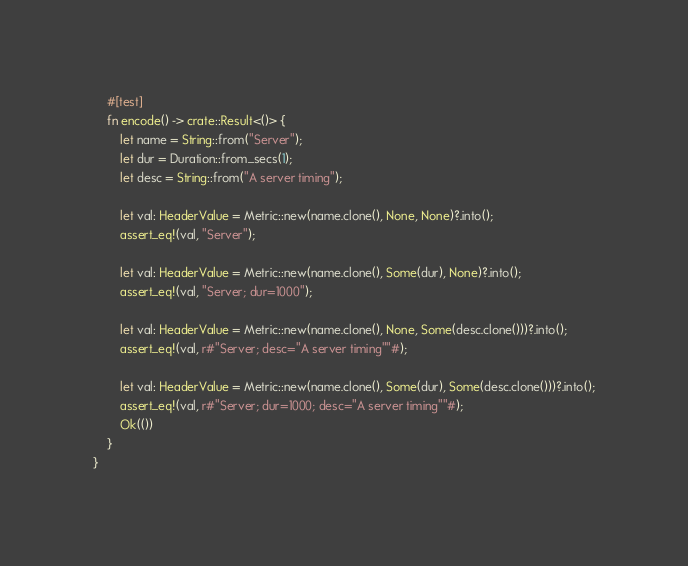<code> <loc_0><loc_0><loc_500><loc_500><_Rust_>    #[test]
    fn encode() -> crate::Result<()> {
        let name = String::from("Server");
        let dur = Duration::from_secs(1);
        let desc = String::from("A server timing");

        let val: HeaderValue = Metric::new(name.clone(), None, None)?.into();
        assert_eq!(val, "Server");

        let val: HeaderValue = Metric::new(name.clone(), Some(dur), None)?.into();
        assert_eq!(val, "Server; dur=1000");

        let val: HeaderValue = Metric::new(name.clone(), None, Some(desc.clone()))?.into();
        assert_eq!(val, r#"Server; desc="A server timing""#);

        let val: HeaderValue = Metric::new(name.clone(), Some(dur), Some(desc.clone()))?.into();
        assert_eq!(val, r#"Server; dur=1000; desc="A server timing""#);
        Ok(())
    }
}
</code> 